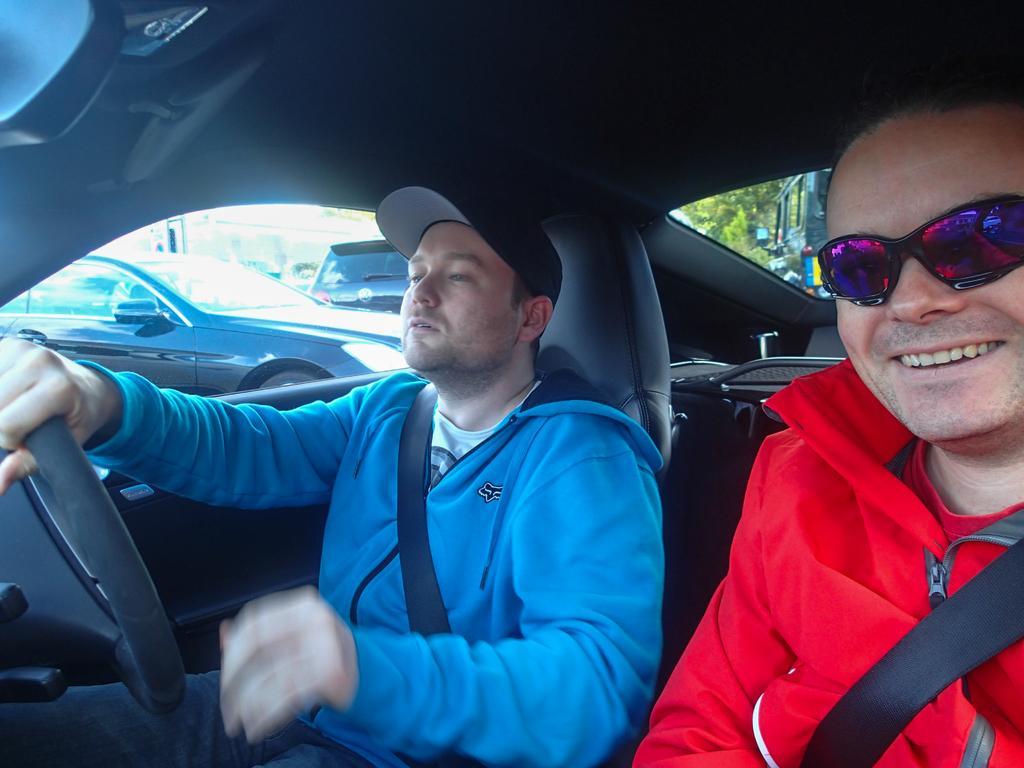Please provide a concise description of this image. In this image we can see two persons sitting inside a car. One person wearing blue coat and a cap is holding steering wheel with his hand. Other person is wearing red coat and goggles. In the background ,we can see group of cars and trees. 